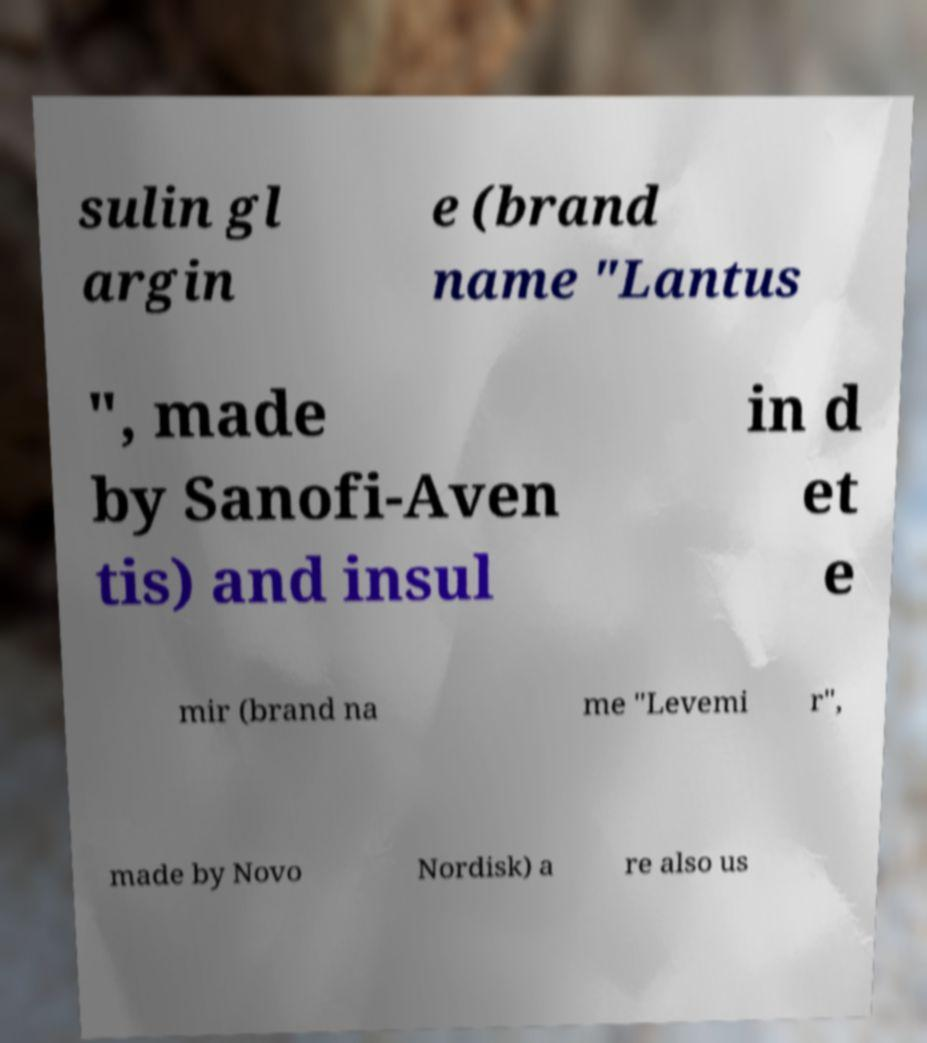Can you read and provide the text displayed in the image?This photo seems to have some interesting text. Can you extract and type it out for me? sulin gl argin e (brand name "Lantus ", made by Sanofi-Aven tis) and insul in d et e mir (brand na me "Levemi r", made by Novo Nordisk) a re also us 